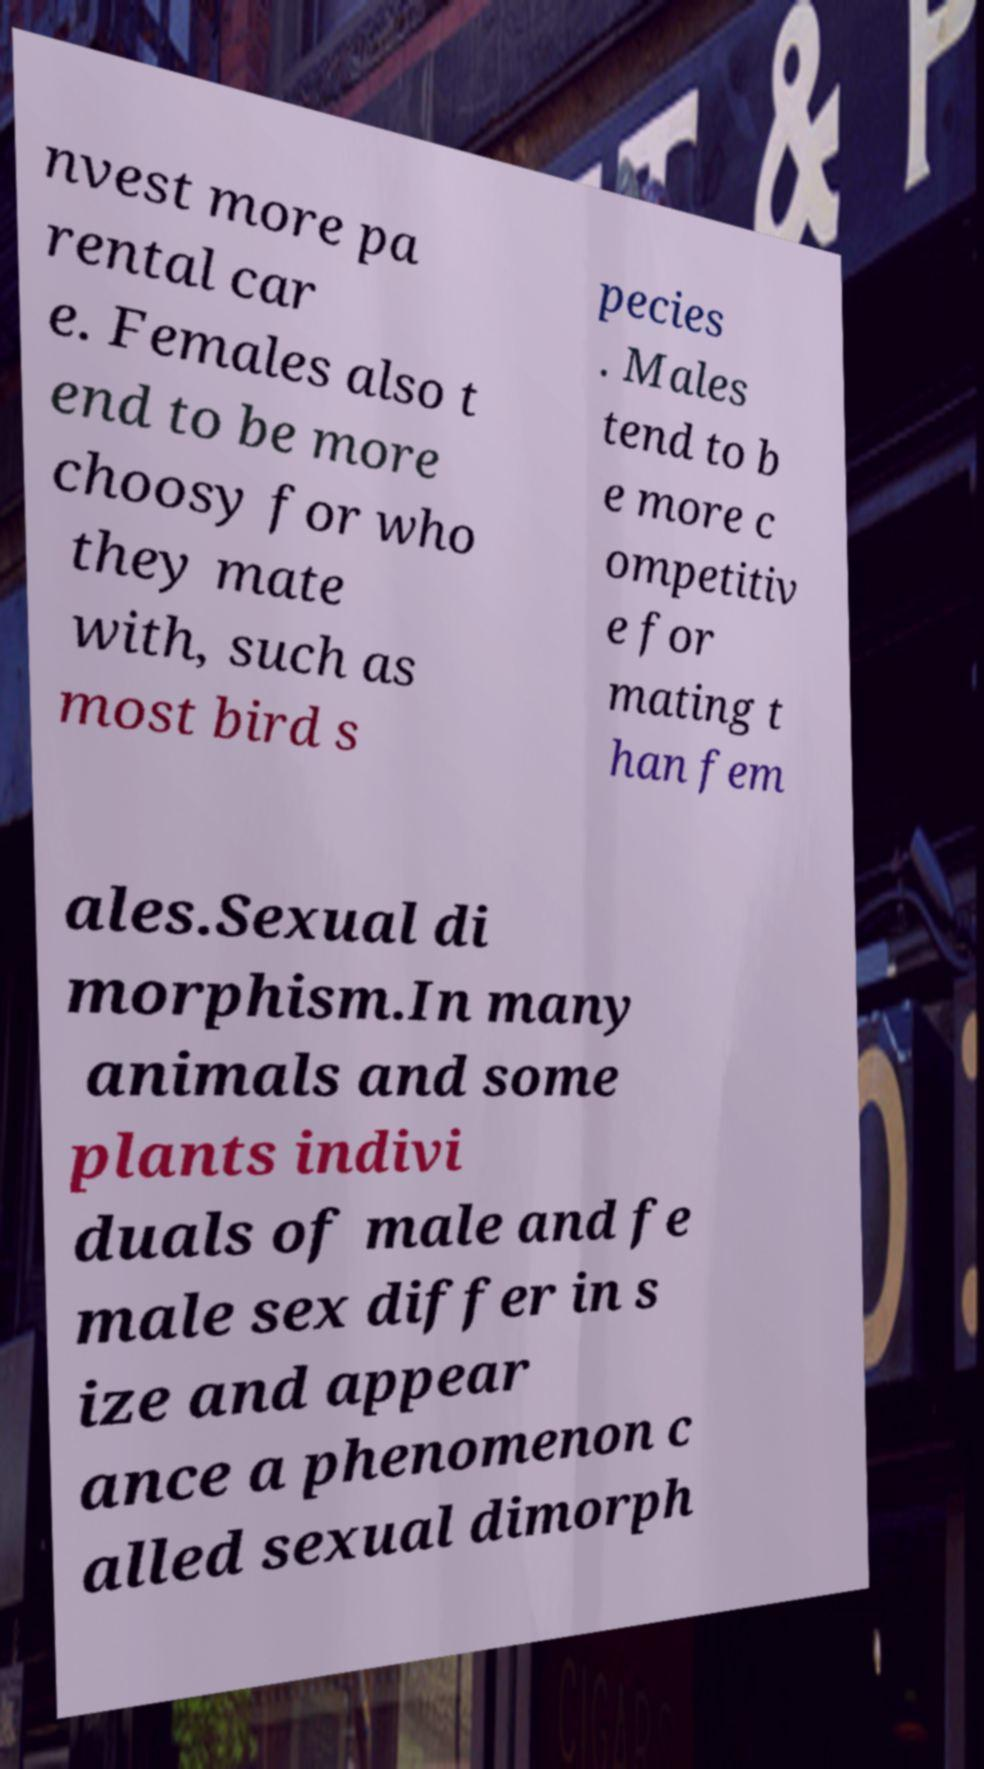Could you assist in decoding the text presented in this image and type it out clearly? nvest more pa rental car e. Females also t end to be more choosy for who they mate with, such as most bird s pecies . Males tend to b e more c ompetitiv e for mating t han fem ales.Sexual di morphism.In many animals and some plants indivi duals of male and fe male sex differ in s ize and appear ance a phenomenon c alled sexual dimorph 